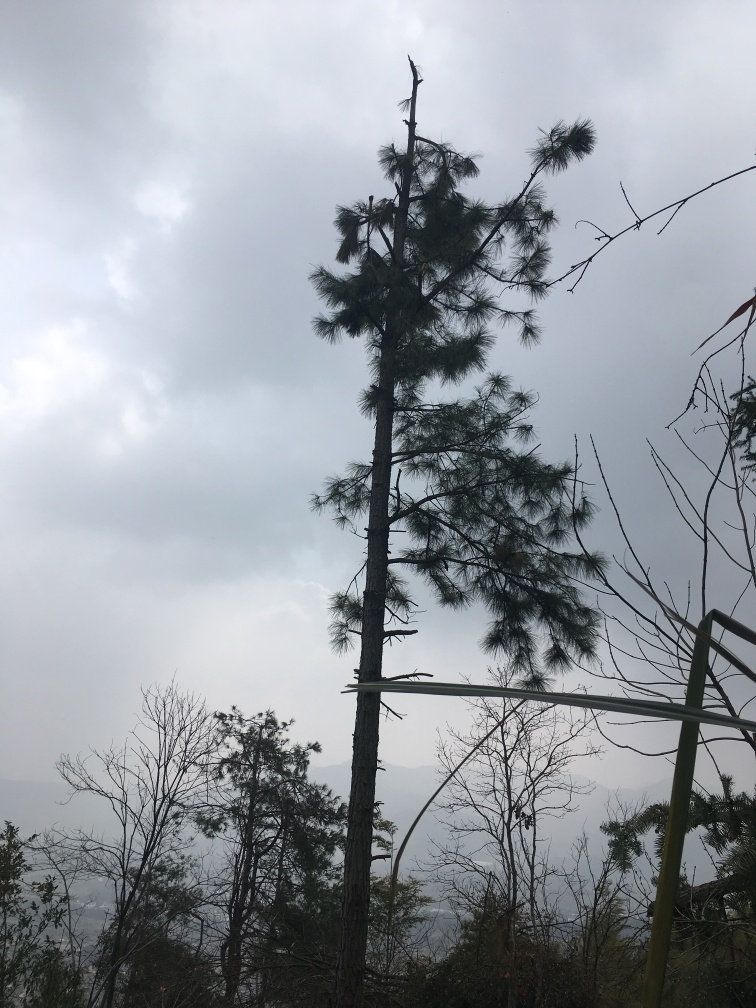What can you tell me about the flora visible in the picture? The image predominantly features evergreen trees, most likely a variety of pine, based on the needle-like leaves and overall shape. There are also deciduous trees with bare branches, possibly suggesting that the photo was taken in a season when these trees are not in full bloom, perhaps autumn or winter. 